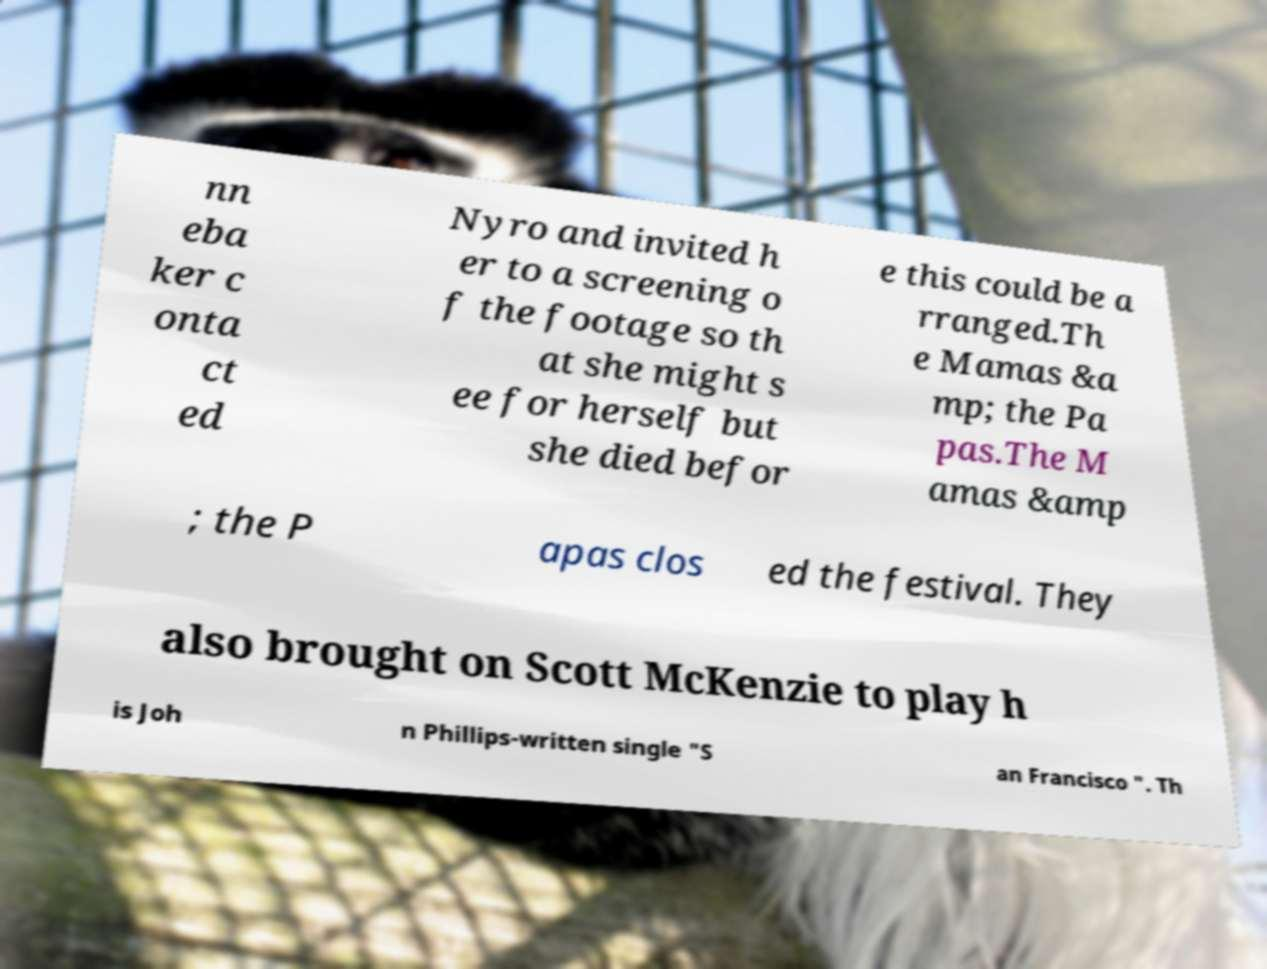Could you assist in decoding the text presented in this image and type it out clearly? nn eba ker c onta ct ed Nyro and invited h er to a screening o f the footage so th at she might s ee for herself but she died befor e this could be a rranged.Th e Mamas &a mp; the Pa pas.The M amas &amp ; the P apas clos ed the festival. They also brought on Scott McKenzie to play h is Joh n Phillips-written single "S an Francisco ". Th 